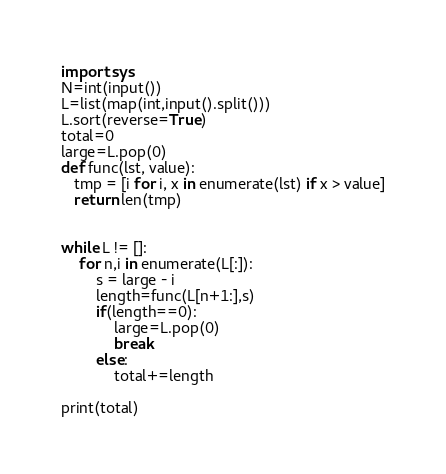<code> <loc_0><loc_0><loc_500><loc_500><_Python_>import sys
N=int(input())
L=list(map(int,input().split()))
L.sort(reverse=True)
total=0
large=L.pop(0)
def func(lst, value):
   tmp = [i for i, x in enumerate(lst) if x > value]
   return len(tmp)


while L != []:
    for n,i in enumerate(L[:]):
        s = large - i
        length=func(L[n+1:],s)
        if(length==0):
            large=L.pop(0)
            break
        else:
            total+=length
    
print(total)</code> 